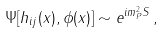Convert formula to latex. <formula><loc_0><loc_0><loc_500><loc_500>\Psi [ h _ { i j } ( x ) , \phi ( x ) ] \sim e ^ { i m _ { P } ^ { 2 } S } \, { , }</formula> 